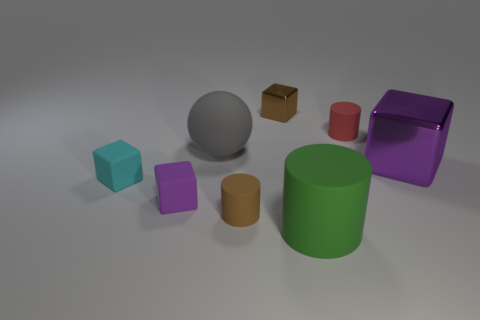Subtract 1 cubes. How many cubes are left? 3 Add 2 large red spheres. How many objects exist? 10 Subtract all cylinders. How many objects are left? 5 Subtract 1 gray balls. How many objects are left? 7 Subtract all cylinders. Subtract all rubber spheres. How many objects are left? 4 Add 4 big purple things. How many big purple things are left? 5 Add 7 cyan rubber blocks. How many cyan rubber blocks exist? 8 